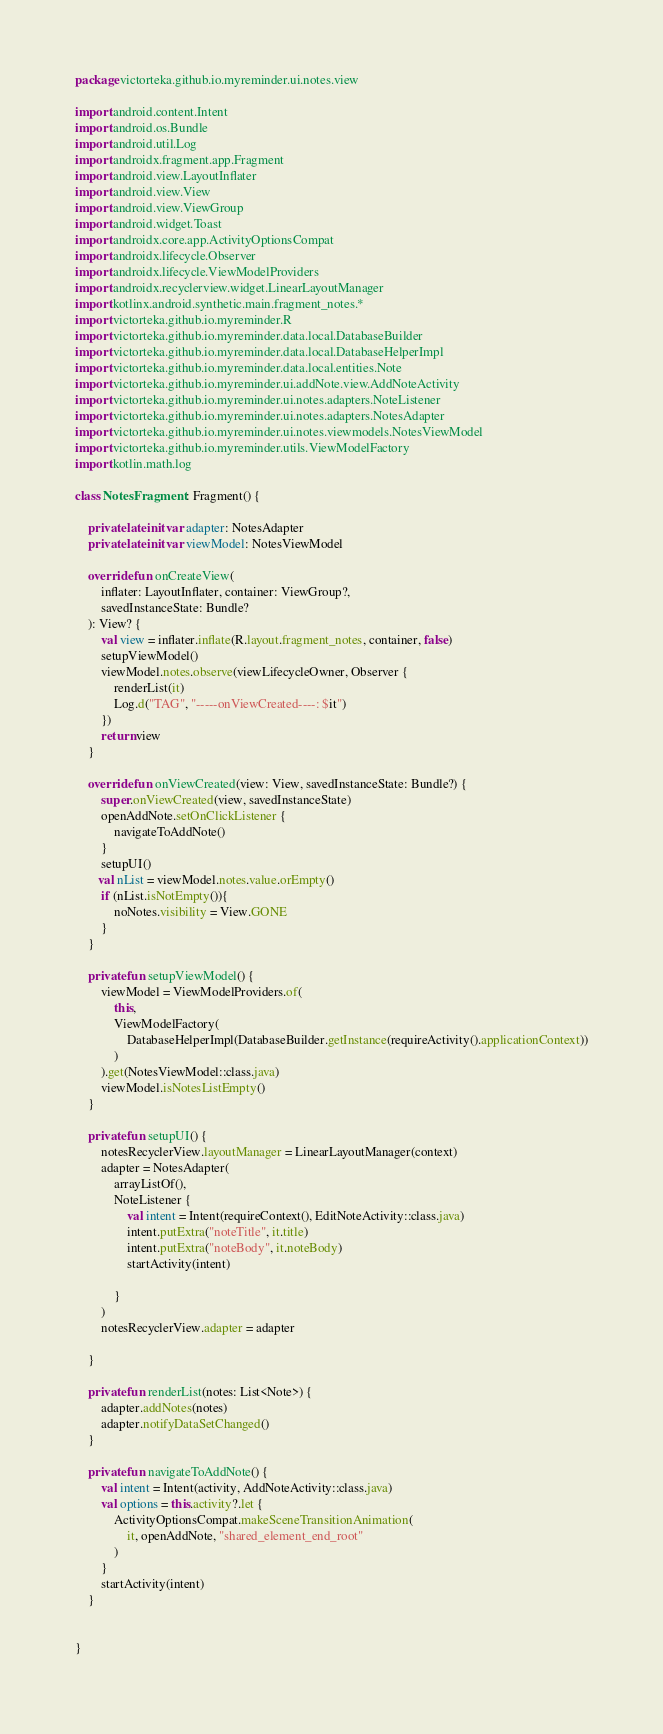Convert code to text. <code><loc_0><loc_0><loc_500><loc_500><_Kotlin_>package victorteka.github.io.myreminder.ui.notes.view

import android.content.Intent
import android.os.Bundle
import android.util.Log
import androidx.fragment.app.Fragment
import android.view.LayoutInflater
import android.view.View
import android.view.ViewGroup
import android.widget.Toast
import androidx.core.app.ActivityOptionsCompat
import androidx.lifecycle.Observer
import androidx.lifecycle.ViewModelProviders
import androidx.recyclerview.widget.LinearLayoutManager
import kotlinx.android.synthetic.main.fragment_notes.*
import victorteka.github.io.myreminder.R
import victorteka.github.io.myreminder.data.local.DatabaseBuilder
import victorteka.github.io.myreminder.data.local.DatabaseHelperImpl
import victorteka.github.io.myreminder.data.local.entities.Note
import victorteka.github.io.myreminder.ui.addNote.view.AddNoteActivity
import victorteka.github.io.myreminder.ui.notes.adapters.NoteListener
import victorteka.github.io.myreminder.ui.notes.adapters.NotesAdapter
import victorteka.github.io.myreminder.ui.notes.viewmodels.NotesViewModel
import victorteka.github.io.myreminder.utils.ViewModelFactory
import kotlin.math.log

class NotesFragment : Fragment() {

    private lateinit var adapter: NotesAdapter
    private lateinit var viewModel: NotesViewModel

    override fun onCreateView(
        inflater: LayoutInflater, container: ViewGroup?,
        savedInstanceState: Bundle?
    ): View? {
        val view = inflater.inflate(R.layout.fragment_notes, container, false)
        setupViewModel()
        viewModel.notes.observe(viewLifecycleOwner, Observer {
            renderList(it)
            Log.d("TAG", "-----onViewCreated----: $it")
        })
        return view
    }

    override fun onViewCreated(view: View, savedInstanceState: Bundle?) {
        super.onViewCreated(view, savedInstanceState)
        openAddNote.setOnClickListener {
            navigateToAddNote()
        }
        setupUI()
       val nList = viewModel.notes.value.orEmpty()
        if (nList.isNotEmpty()){
            noNotes.visibility = View.GONE
        }
    }

    private fun setupViewModel() {
        viewModel = ViewModelProviders.of(
            this,
            ViewModelFactory(
                DatabaseHelperImpl(DatabaseBuilder.getInstance(requireActivity().applicationContext))
            )
        ).get(NotesViewModel::class.java)
        viewModel.isNotesListEmpty()
    }

    private fun setupUI() {
        notesRecyclerView.layoutManager = LinearLayoutManager(context)
        adapter = NotesAdapter(
            arrayListOf(),
            NoteListener {
                val intent = Intent(requireContext(), EditNoteActivity::class.java)
                intent.putExtra("noteTitle", it.title)
                intent.putExtra("noteBody", it.noteBody)
                startActivity(intent)

            }
        )
        notesRecyclerView.adapter = adapter

    }

    private fun renderList(notes: List<Note>) {
        adapter.addNotes(notes)
        adapter.notifyDataSetChanged()
    }

    private fun navigateToAddNote() {
        val intent = Intent(activity, AddNoteActivity::class.java)
        val options = this.activity?.let {
            ActivityOptionsCompat.makeSceneTransitionAnimation(
                it, openAddNote, "shared_element_end_root"
            )
        }
        startActivity(intent)
    }


}</code> 